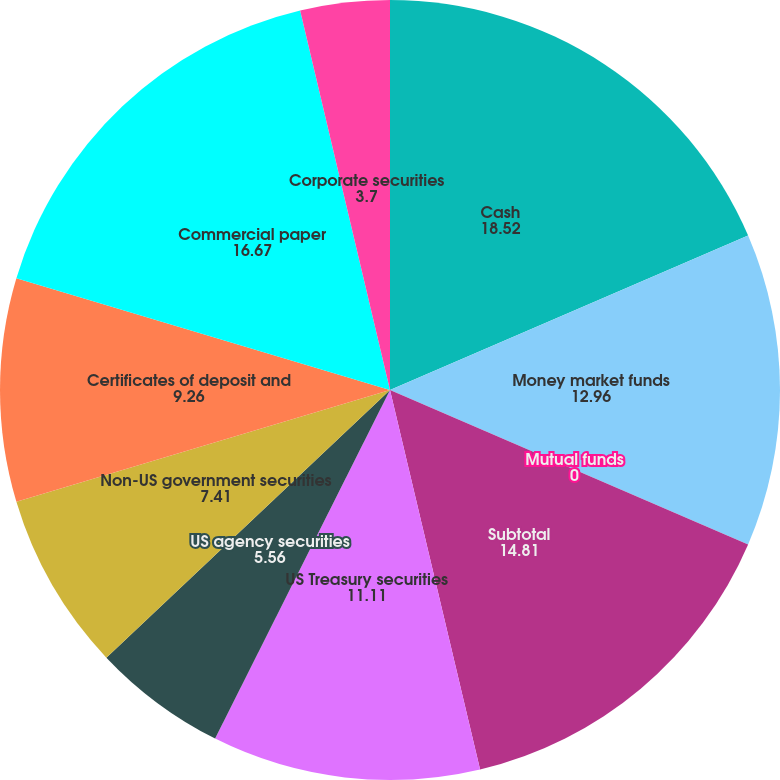Convert chart to OTSL. <chart><loc_0><loc_0><loc_500><loc_500><pie_chart><fcel>Cash<fcel>Money market funds<fcel>Mutual funds<fcel>Subtotal<fcel>US Treasury securities<fcel>US agency securities<fcel>Non-US government securities<fcel>Certificates of deposit and<fcel>Commercial paper<fcel>Corporate securities<nl><fcel>18.52%<fcel>12.96%<fcel>0.0%<fcel>14.81%<fcel>11.11%<fcel>5.56%<fcel>7.41%<fcel>9.26%<fcel>16.67%<fcel>3.7%<nl></chart> 